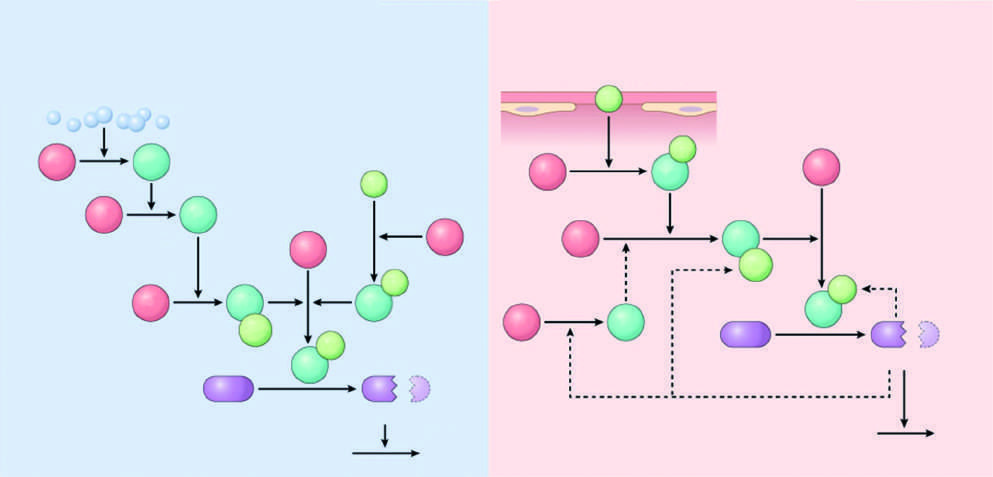re the dark green polypeptides active factors?
Answer the question using a single word or phrase. Yes 